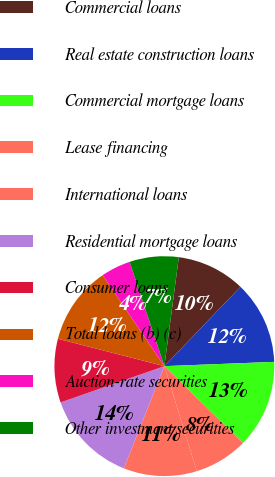Convert chart to OTSL. <chart><loc_0><loc_0><loc_500><loc_500><pie_chart><fcel>Commercial loans<fcel>Real estate construction loans<fcel>Commercial mortgage loans<fcel>Lease financing<fcel>International loans<fcel>Residential mortgage loans<fcel>Consumer loans<fcel>Total loans (b) (c)<fcel>Auction-rate securities<fcel>Other investment securities<nl><fcel>10.07%<fcel>12.21%<fcel>12.92%<fcel>7.93%<fcel>10.78%<fcel>13.63%<fcel>9.36%<fcel>11.5%<fcel>4.37%<fcel>7.22%<nl></chart> 